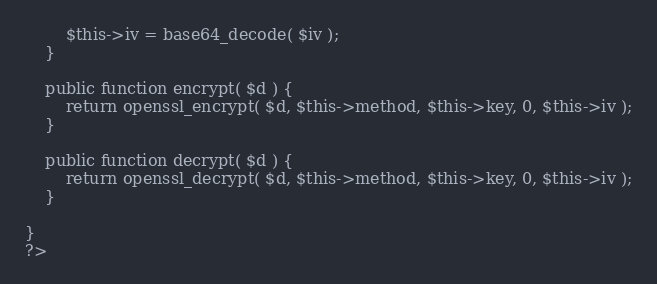<code> <loc_0><loc_0><loc_500><loc_500><_PHP_>		$this->iv = base64_decode( $iv );
	}

	public function encrypt( $d ) {
		return openssl_encrypt( $d, $this->method, $this->key, 0, $this->iv );
	}

	public function decrypt( $d ) {
		return openssl_decrypt( $d, $this->method, $this->key, 0, $this->iv );
	}

}
?></code> 